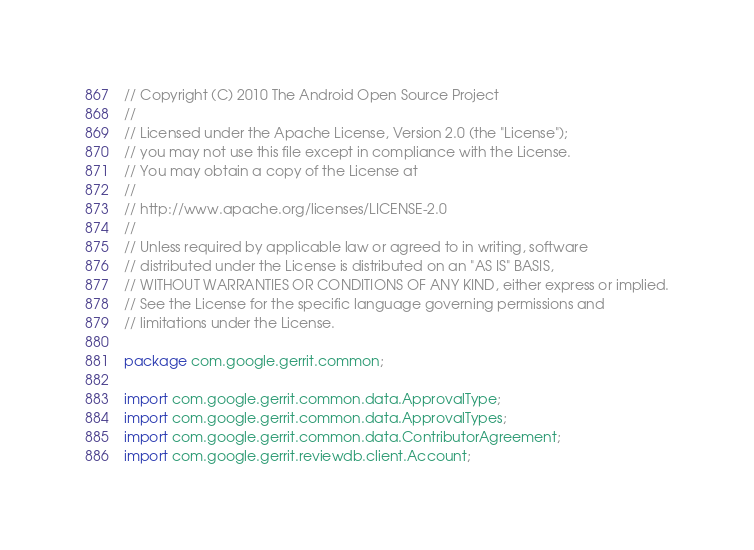<code> <loc_0><loc_0><loc_500><loc_500><_Java_>// Copyright (C) 2010 The Android Open Source Project
//
// Licensed under the Apache License, Version 2.0 (the "License");
// you may not use this file except in compliance with the License.
// You may obtain a copy of the License at
//
// http://www.apache.org/licenses/LICENSE-2.0
//
// Unless required by applicable law or agreed to in writing, software
// distributed under the License is distributed on an "AS IS" BASIS,
// WITHOUT WARRANTIES OR CONDITIONS OF ANY KIND, either express or implied.
// See the License for the specific language governing permissions and
// limitations under the License.

package com.google.gerrit.common;

import com.google.gerrit.common.data.ApprovalType;
import com.google.gerrit.common.data.ApprovalTypes;
import com.google.gerrit.common.data.ContributorAgreement;
import com.google.gerrit.reviewdb.client.Account;</code> 